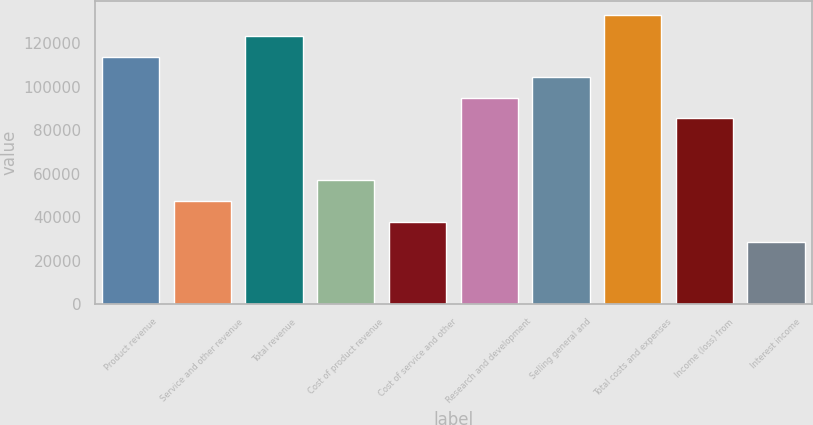Convert chart. <chart><loc_0><loc_0><loc_500><loc_500><bar_chart><fcel>Product revenue<fcel>Service and other revenue<fcel>Total revenue<fcel>Cost of product revenue<fcel>Cost of service and other<fcel>Research and development<fcel>Selling general and<fcel>Total costs and expenses<fcel>Income (loss) from<fcel>Interest income<nl><fcel>113938<fcel>47474.3<fcel>123432<fcel>56969<fcel>37979.5<fcel>94948<fcel>104443<fcel>132927<fcel>85453.3<fcel>28484.8<nl></chart> 